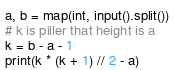<code> <loc_0><loc_0><loc_500><loc_500><_Python_>a, b = map(int, input().split())
# k is piller that height is a
k = b - a - 1
print(k * (k + 1) // 2 - a)</code> 